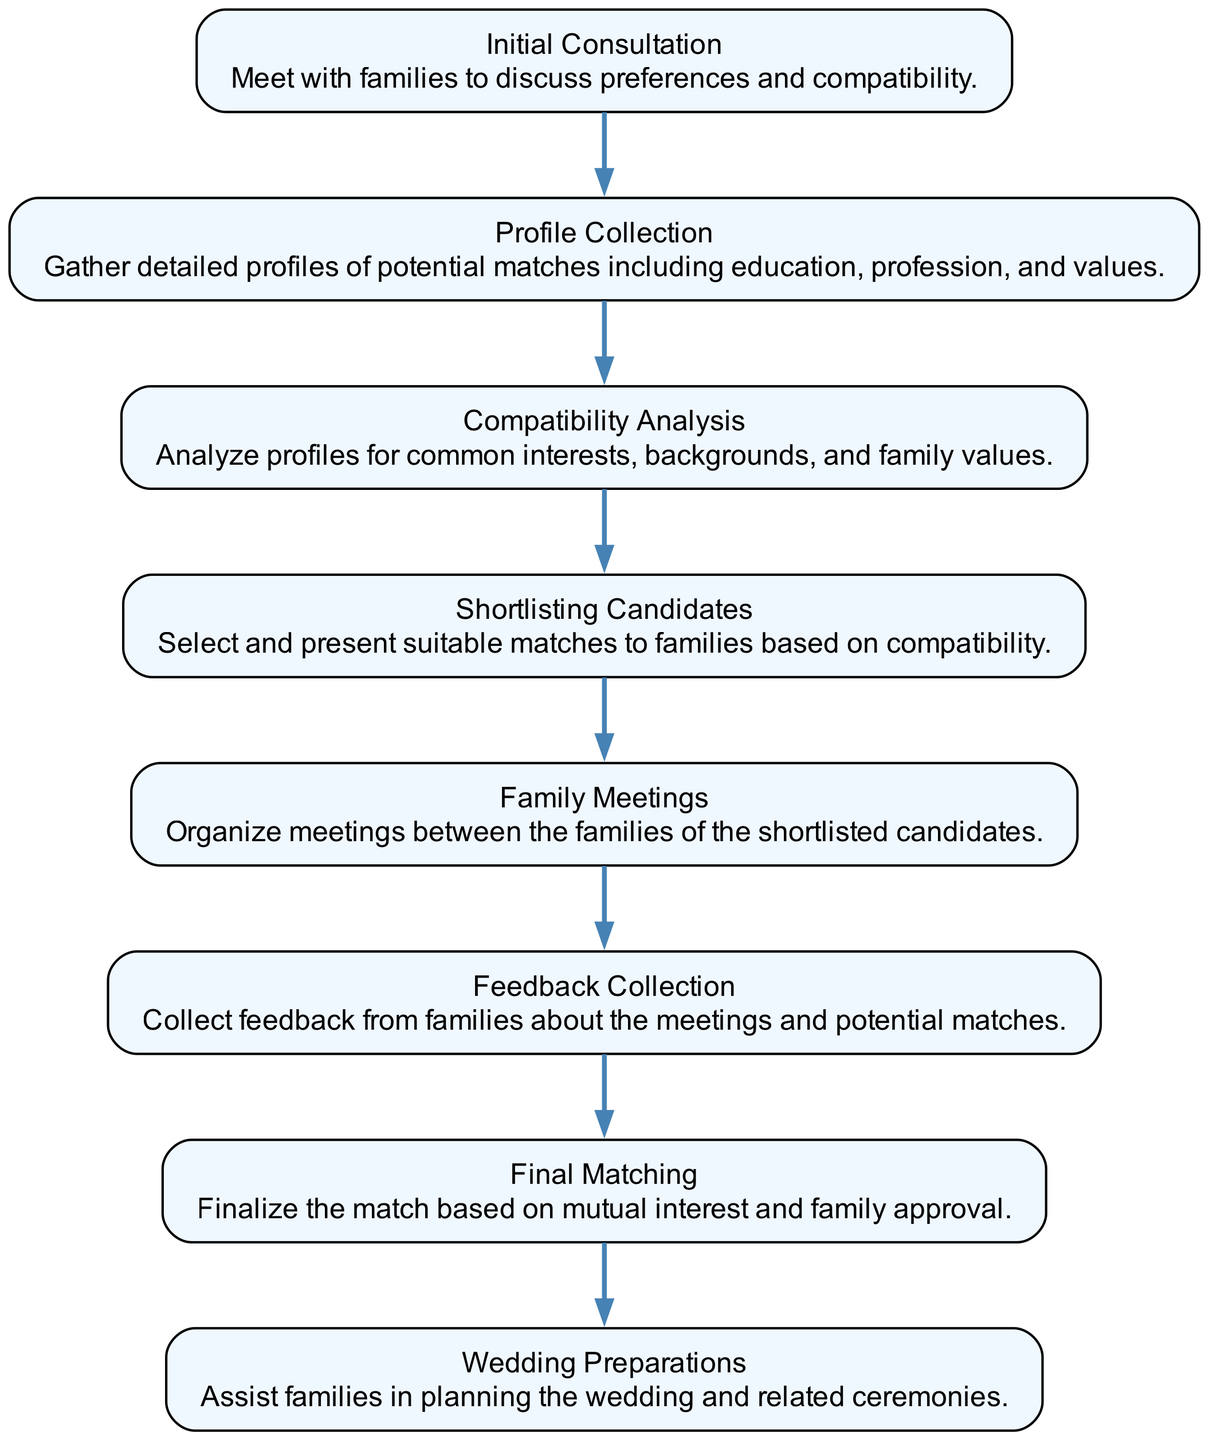What is the first step in the matching process? The first step is defined as "Initial Consultation" where families meet to discuss preferences and compatibility.
Answer: Initial Consultation How many steps are there in the matching process? The diagram indicates there are eight steps in total, as there are eight elements listed.
Answer: Eight What follows "Compatibility Analysis"? The step that follows "Compatibility Analysis" is "Shortlisting Candidates," presenting suitable matches based on compatibility analysis results.
Answer: Shortlisting Candidates Which step assists families in planning the wedding? The step that assists families in planning the wedding is "Wedding Preparations," where support is provided for the wedding and related ceremonies.
Answer: Wedding Preparations What is collected after family meetings? The information collected after family meetings is referred to as "Feedback Collection," which gathers opinions from families regarding the meetings and potential matches.
Answer: Feedback Collection How many edges are present in this flow chart? The flow chart consists of seven edges, as each step leads to the next one until the final step.
Answer: Seven What do families discuss in the initial consultation? Families discuss preferences and compatibility during the "Initial Consultation," as specified in the description of this step.
Answer: Preferences and compatibility What is the last step in the matching process? The last step in the matching process is "Wedding Preparations," which implies that after the final matching, preparations for the wedding ensue.
Answer: Wedding Preparations 